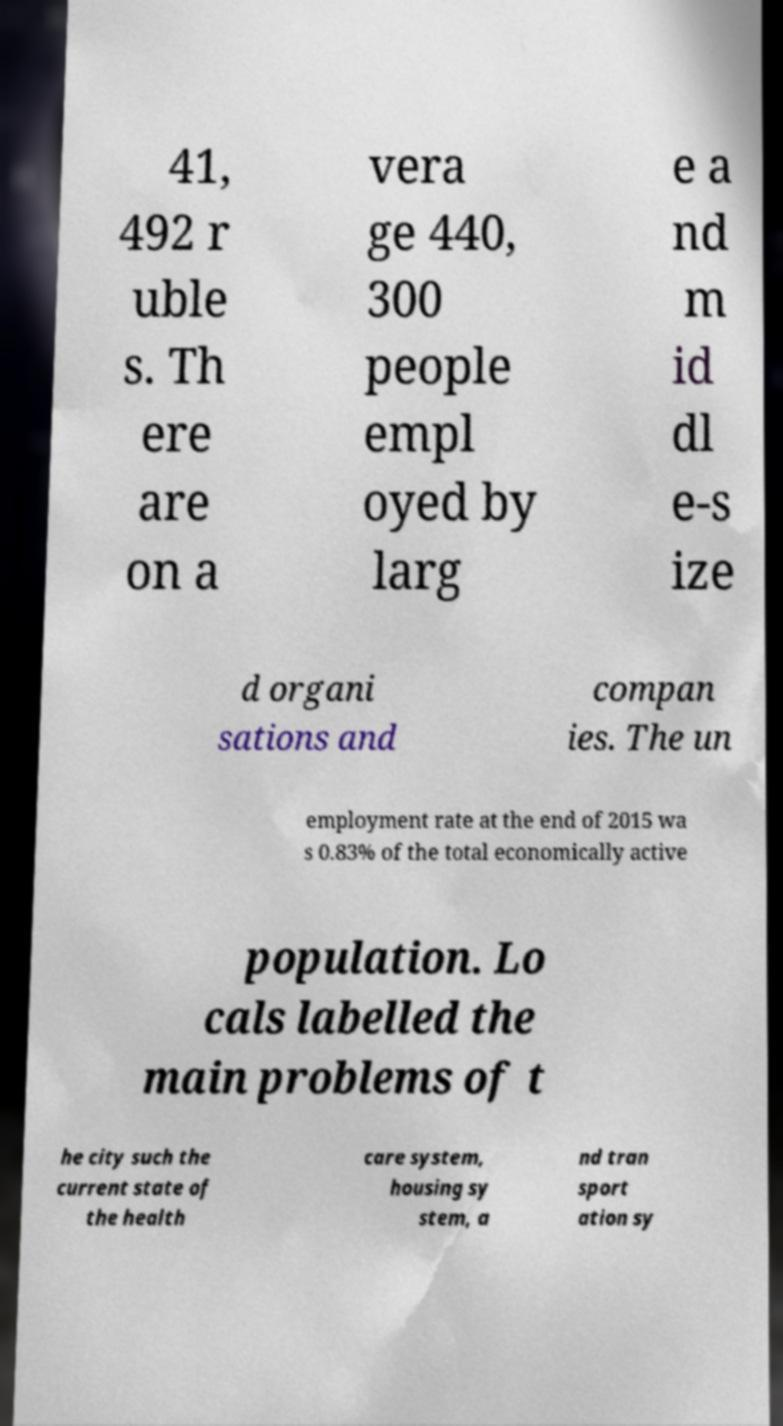I need the written content from this picture converted into text. Can you do that? 41, 492 r uble s. Th ere are on a vera ge 440, 300 people empl oyed by larg e a nd m id dl e-s ize d organi sations and compan ies. The un employment rate at the end of 2015 wa s 0.83% of the total economically active population. Lo cals labelled the main problems of t he city such the current state of the health care system, housing sy stem, a nd tran sport ation sy 